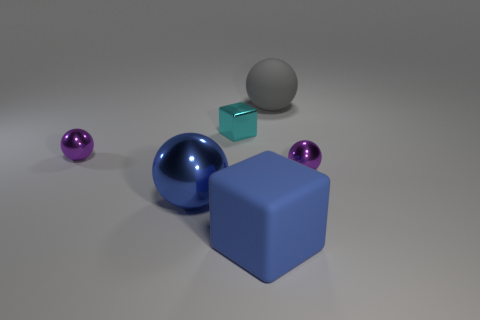Subtract all blue blocks. How many blocks are left? 1 Subtract all large matte balls. How many balls are left? 3 Subtract 3 spheres. How many spheres are left? 1 Subtract all yellow spheres. Subtract all brown cylinders. How many spheres are left? 4 Subtract all red cubes. How many purple spheres are left? 2 Subtract all rubber spheres. Subtract all big blue cubes. How many objects are left? 4 Add 4 large shiny things. How many large shiny things are left? 5 Add 1 small gray shiny things. How many small gray shiny things exist? 1 Add 3 large blue objects. How many objects exist? 9 Subtract 0 purple cylinders. How many objects are left? 6 